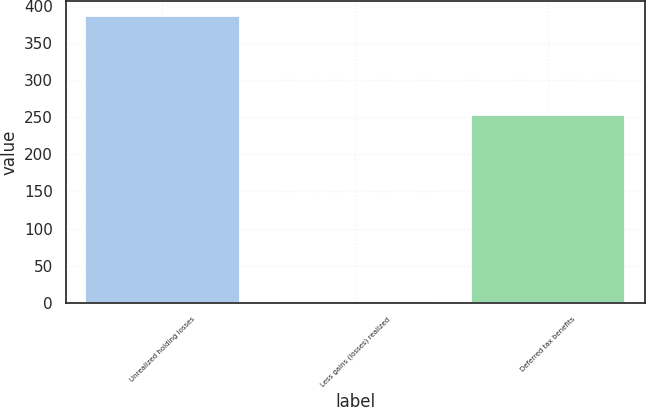Convert chart. <chart><loc_0><loc_0><loc_500><loc_500><bar_chart><fcel>Unrealized holding losses<fcel>Less gains (losses) realized<fcel>Deferred tax benefits<nl><fcel>387<fcel>3<fcel>253<nl></chart> 